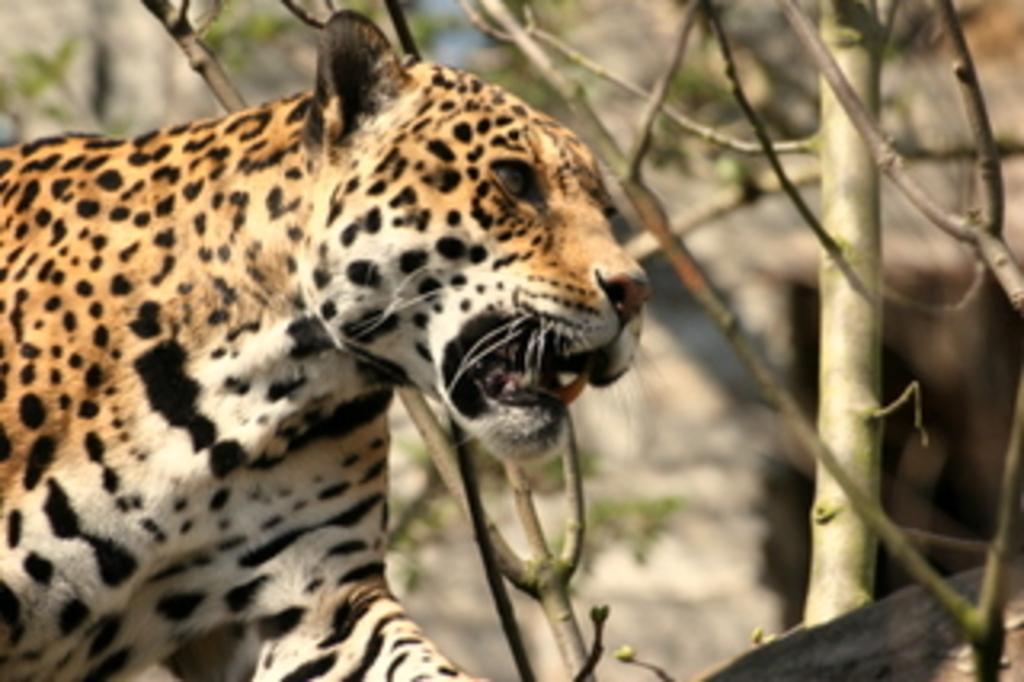Describe this image in one or two sentences. In this image I can see a tiger on the left hand side of the image. I can see some dried stems of the trees with a blurred background. 